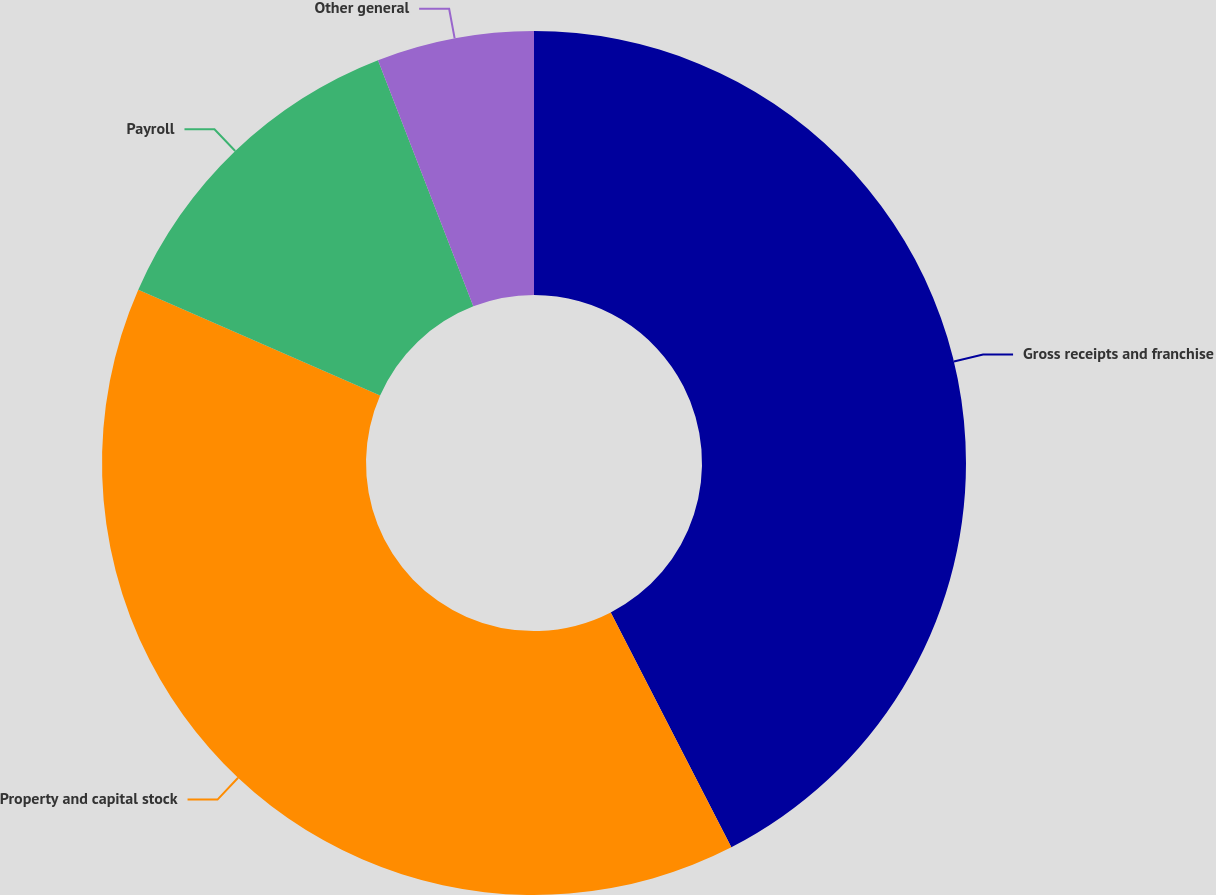Convert chart. <chart><loc_0><loc_0><loc_500><loc_500><pie_chart><fcel>Gross receipts and franchise<fcel>Property and capital stock<fcel>Payroll<fcel>Other general<nl><fcel>42.45%<fcel>39.12%<fcel>12.55%<fcel>5.88%<nl></chart> 